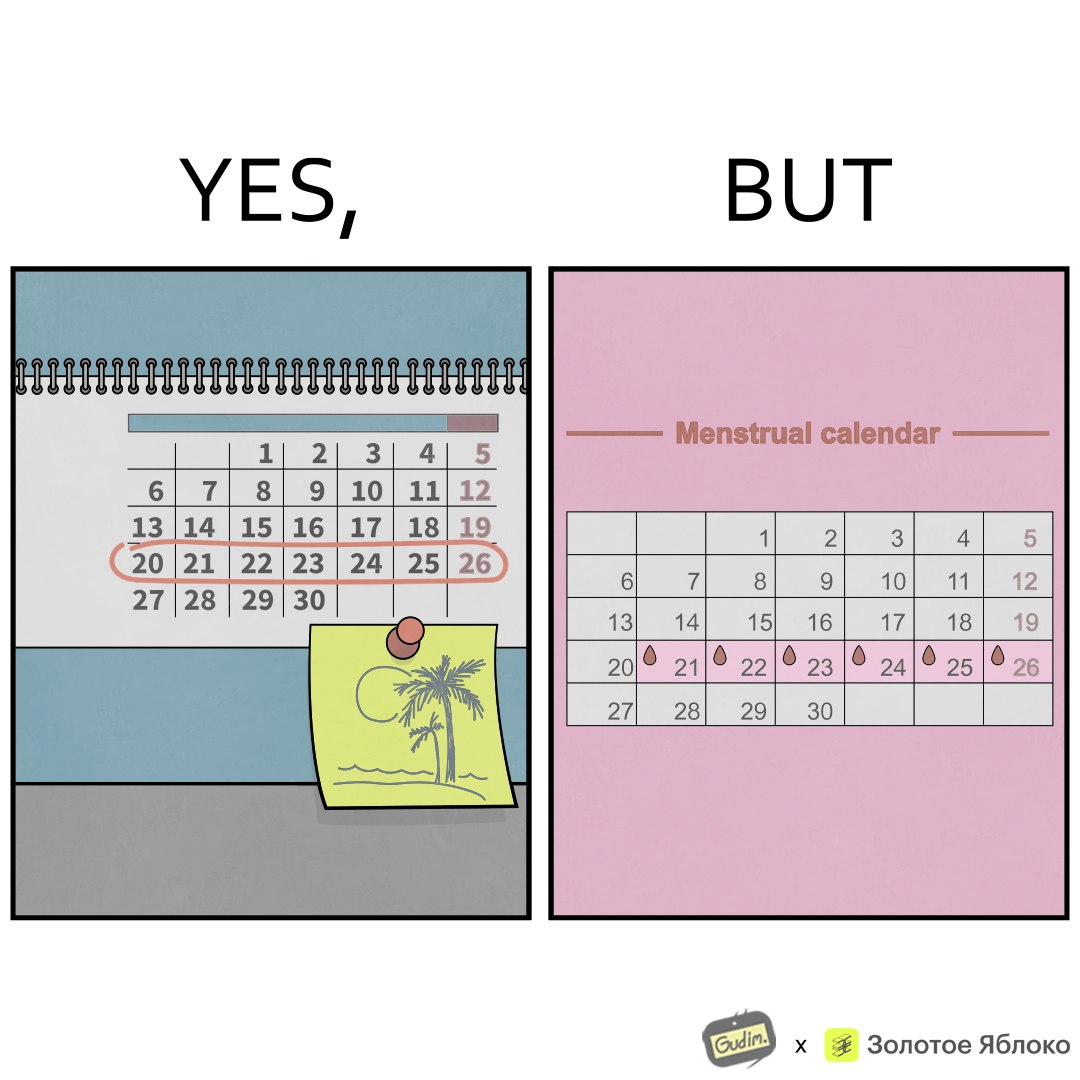What do you see in each half of this image? In the left part of the image: It is a calendar marked with holidays and a planned vacation In the right part of the image: It is a menstrual calendar with the menstruation days marked on it 